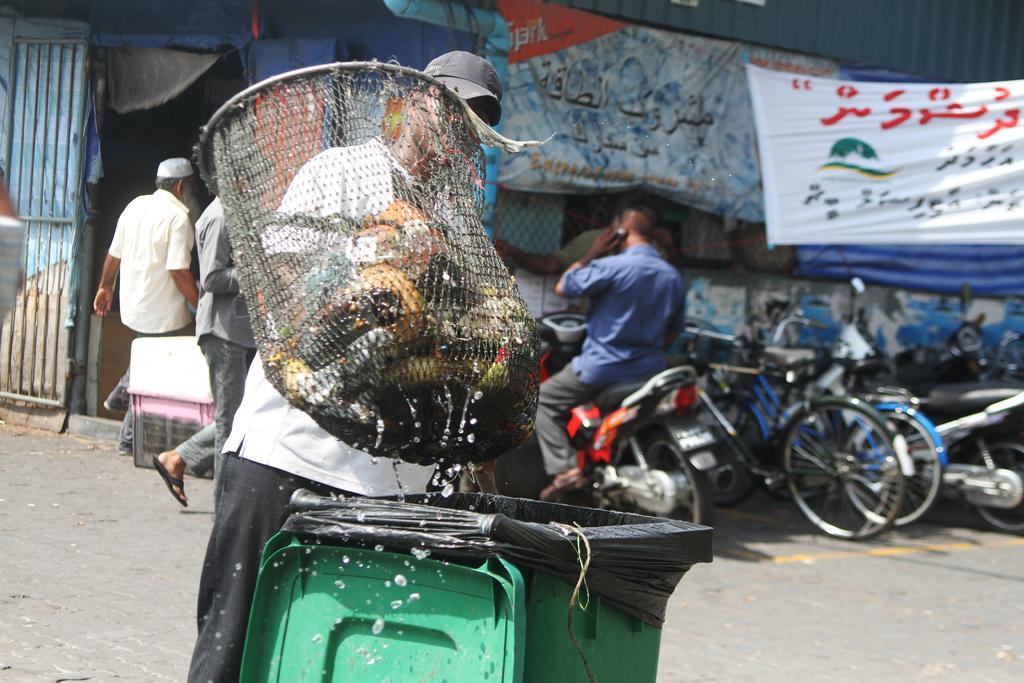In one or two sentences, can you explain what this image depicts? On the background we can see banners. We can see persons walking and a man sitting on a bike , he is on a call. We can see vehicles parked here. Here we can see one man holding a net with his hand and he is throwing the net in a trash can which is on the road. 